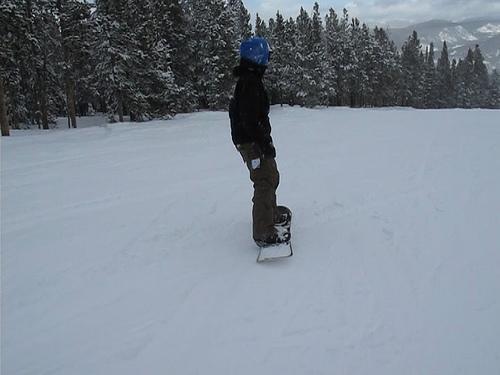How many people are shown?
Give a very brief answer. 1. 